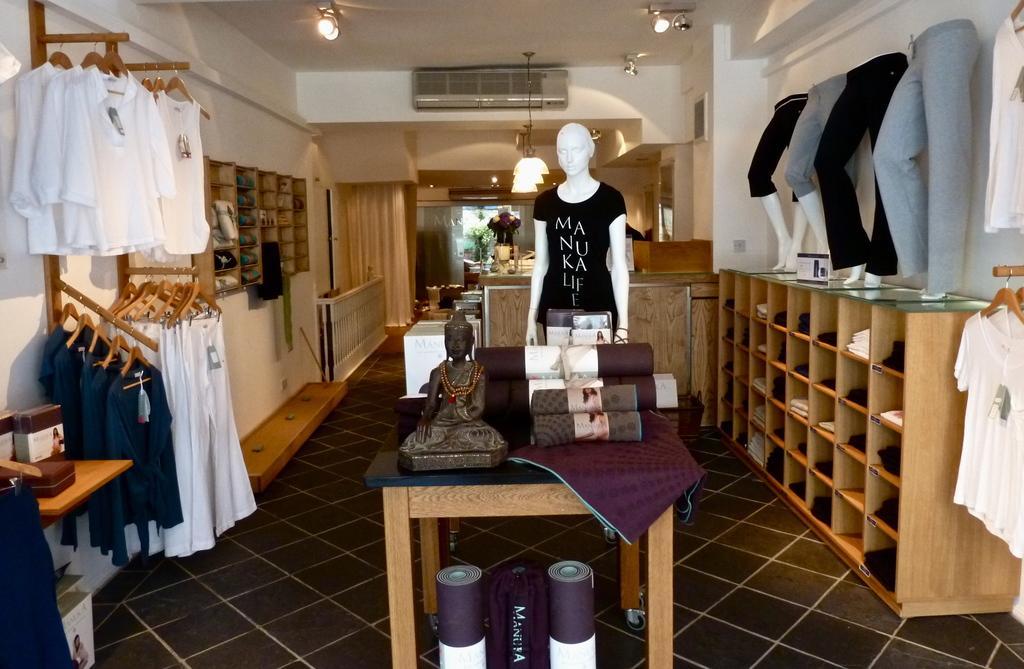Please provide a concise description of this image. In this picture we can see a statue on the platform and this platform is on the floor, here we can see mannequins, clothes, shelves, lights and some objects and in the background we can see a wall, roof. 